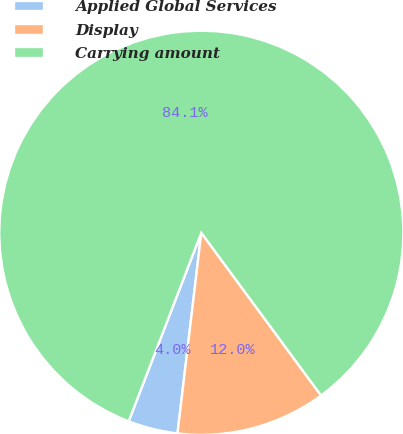<chart> <loc_0><loc_0><loc_500><loc_500><pie_chart><fcel>Applied Global Services<fcel>Display<fcel>Carrying amount<nl><fcel>3.97%<fcel>11.98%<fcel>84.05%<nl></chart> 